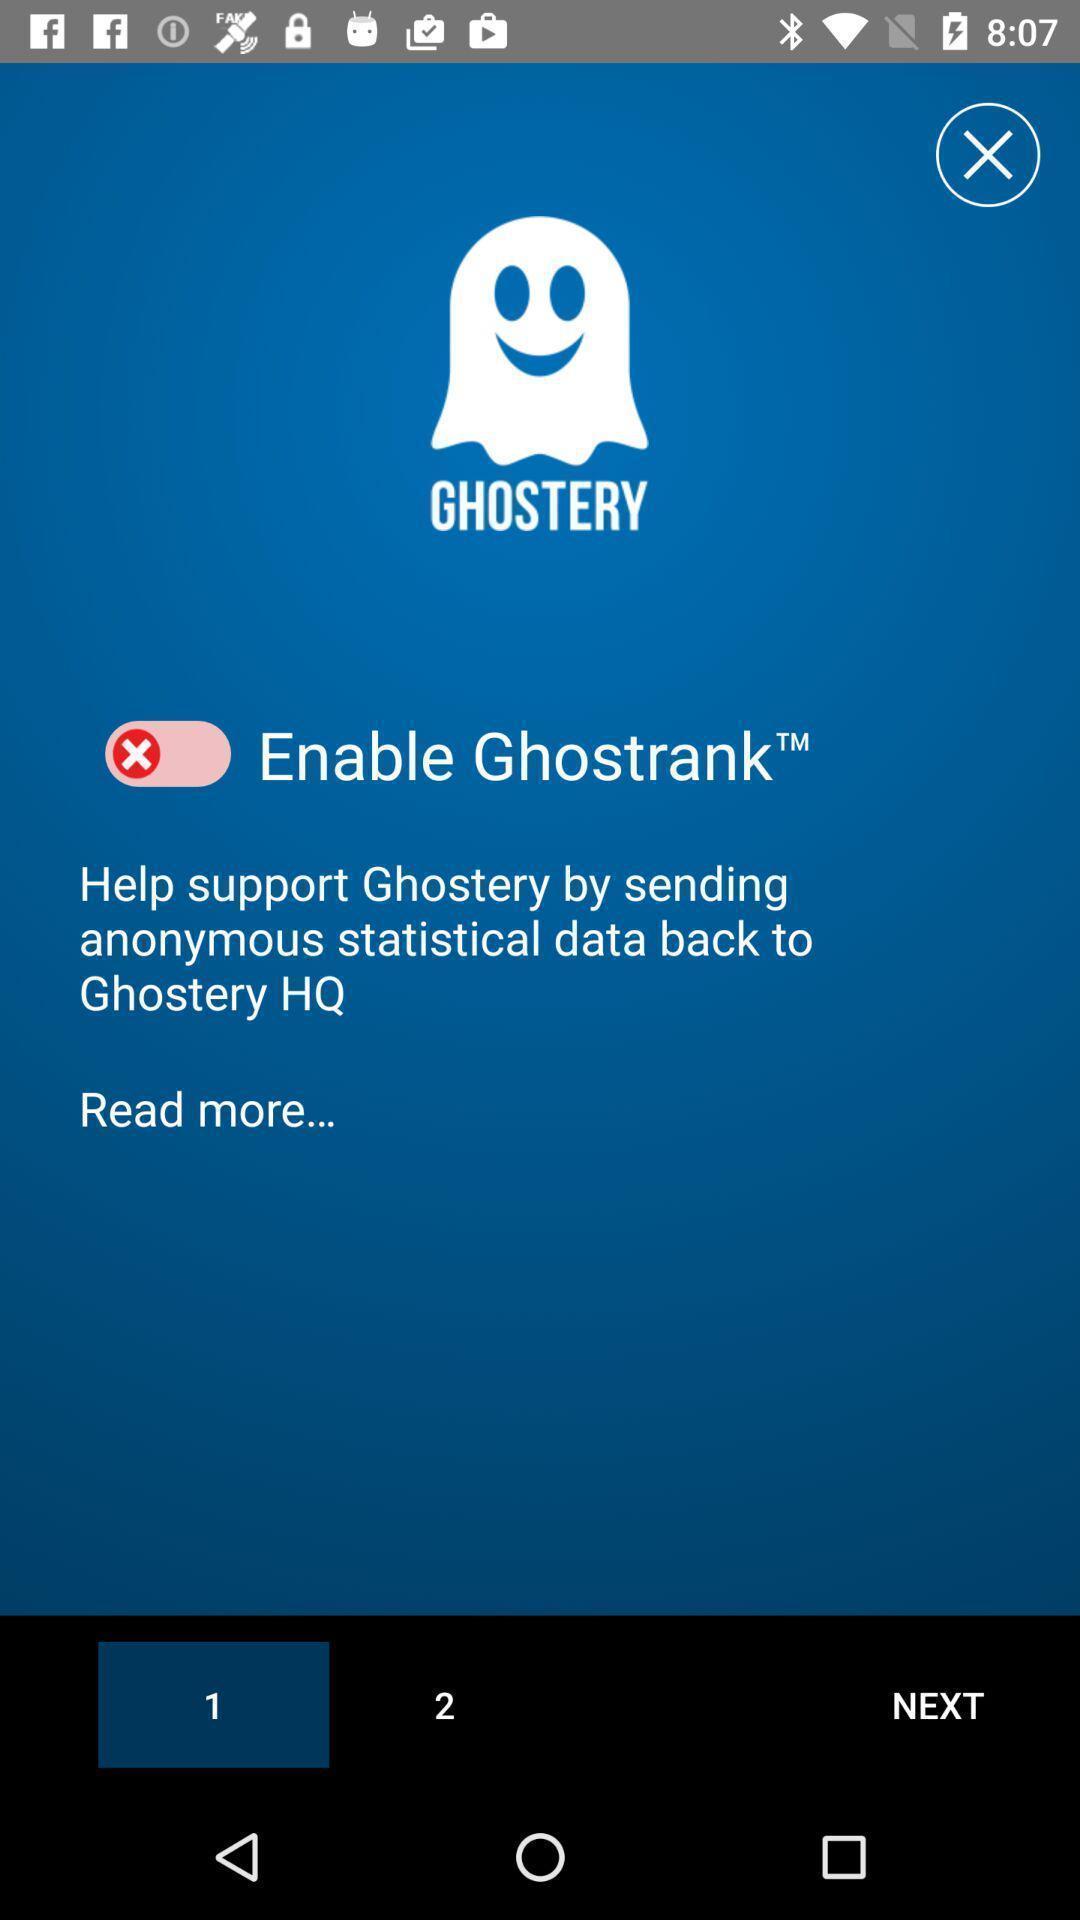Explain the elements present in this screenshot. Screen shows a tracker information for browsing. 